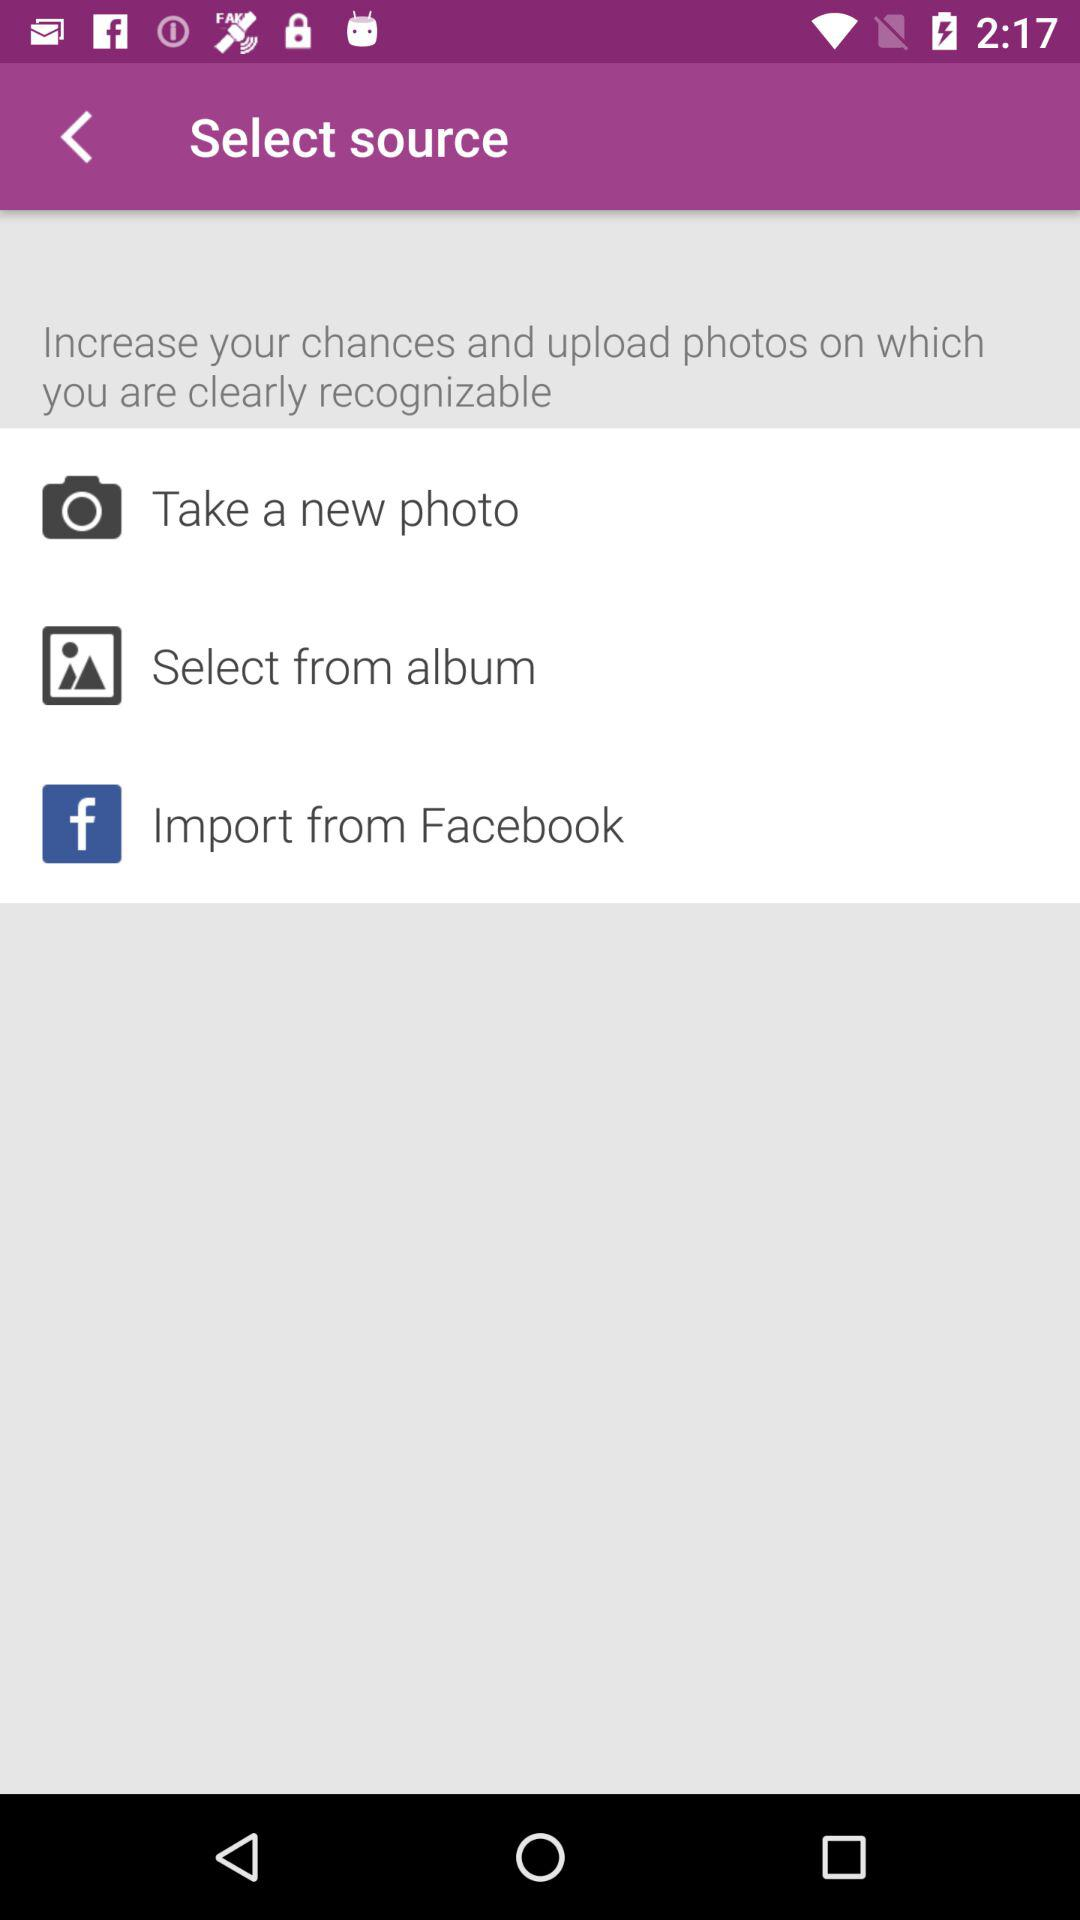How many ways are there to upload a photo?
Answer the question using a single word or phrase. 3 